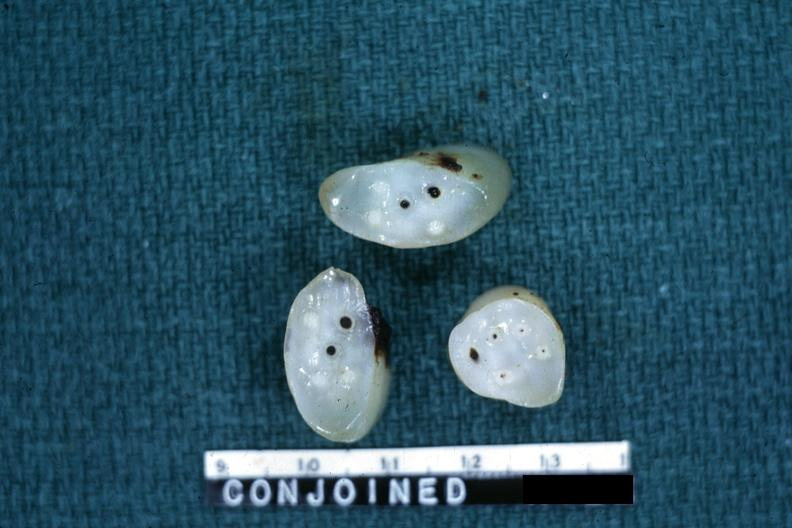s hemochromatosis present?
Answer the question using a single word or phrase. No 